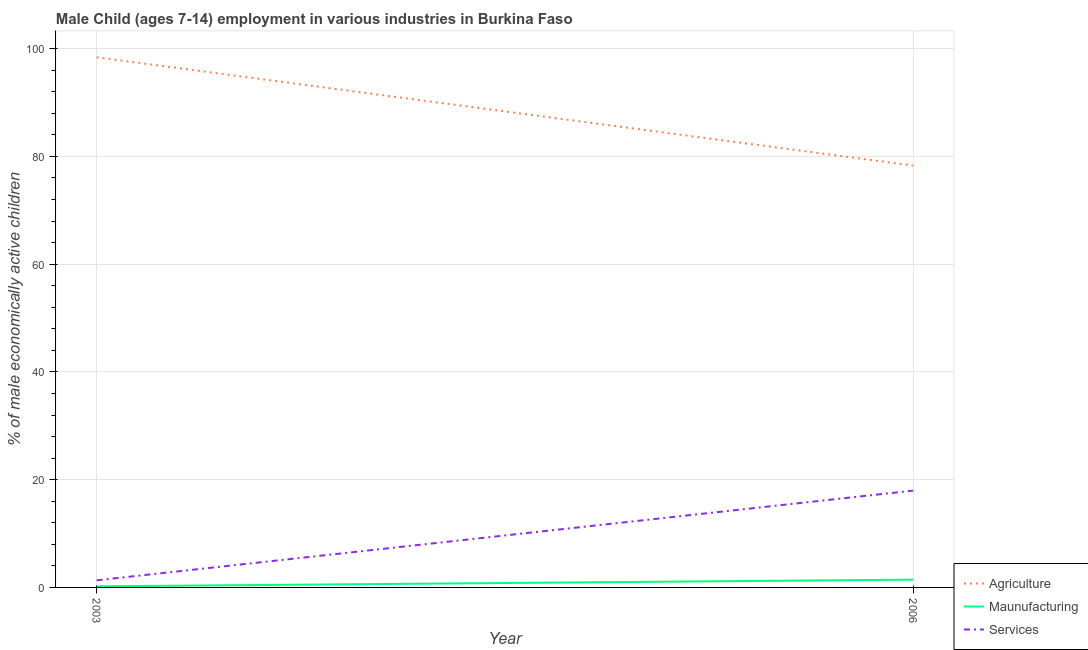How many different coloured lines are there?
Ensure brevity in your answer.  3. Is the number of lines equal to the number of legend labels?
Provide a succinct answer. Yes. What is the percentage of economically active children in manufacturing in 2006?
Your response must be concise. 1.44. Across all years, what is the maximum percentage of economically active children in services?
Provide a short and direct response. 17.97. Across all years, what is the minimum percentage of economically active children in agriculture?
Give a very brief answer. 78.3. In which year was the percentage of economically active children in manufacturing maximum?
Make the answer very short. 2006. In which year was the percentage of economically active children in services minimum?
Your response must be concise. 2003. What is the total percentage of economically active children in manufacturing in the graph?
Give a very brief answer. 1.64. What is the difference between the percentage of economically active children in manufacturing in 2003 and that in 2006?
Your answer should be compact. -1.24. What is the difference between the percentage of economically active children in agriculture in 2006 and the percentage of economically active children in services in 2003?
Ensure brevity in your answer.  76.98. What is the average percentage of economically active children in services per year?
Provide a succinct answer. 9.65. In the year 2003, what is the difference between the percentage of economically active children in agriculture and percentage of economically active children in manufacturing?
Make the answer very short. 98.2. What is the ratio of the percentage of economically active children in agriculture in 2003 to that in 2006?
Your answer should be compact. 1.26. Does the percentage of economically active children in manufacturing monotonically increase over the years?
Provide a succinct answer. Yes. Is the percentage of economically active children in services strictly less than the percentage of economically active children in manufacturing over the years?
Keep it short and to the point. No. How many lines are there?
Make the answer very short. 3. Does the graph contain grids?
Your answer should be compact. Yes. How are the legend labels stacked?
Offer a terse response. Vertical. What is the title of the graph?
Make the answer very short. Male Child (ages 7-14) employment in various industries in Burkina Faso. What is the label or title of the X-axis?
Ensure brevity in your answer.  Year. What is the label or title of the Y-axis?
Your answer should be compact. % of male economically active children. What is the % of male economically active children in Agriculture in 2003?
Your answer should be very brief. 98.4. What is the % of male economically active children of Maunufacturing in 2003?
Provide a succinct answer. 0.2. What is the % of male economically active children in Services in 2003?
Keep it short and to the point. 1.32. What is the % of male economically active children in Agriculture in 2006?
Provide a short and direct response. 78.3. What is the % of male economically active children of Maunufacturing in 2006?
Provide a short and direct response. 1.44. What is the % of male economically active children of Services in 2006?
Ensure brevity in your answer.  17.97. Across all years, what is the maximum % of male economically active children in Agriculture?
Offer a terse response. 98.4. Across all years, what is the maximum % of male economically active children of Maunufacturing?
Provide a succinct answer. 1.44. Across all years, what is the maximum % of male economically active children in Services?
Ensure brevity in your answer.  17.97. Across all years, what is the minimum % of male economically active children of Agriculture?
Give a very brief answer. 78.3. Across all years, what is the minimum % of male economically active children in Services?
Offer a very short reply. 1.32. What is the total % of male economically active children of Agriculture in the graph?
Offer a terse response. 176.7. What is the total % of male economically active children in Maunufacturing in the graph?
Provide a succinct answer. 1.64. What is the total % of male economically active children of Services in the graph?
Your answer should be compact. 19.29. What is the difference between the % of male economically active children in Agriculture in 2003 and that in 2006?
Make the answer very short. 20.1. What is the difference between the % of male economically active children in Maunufacturing in 2003 and that in 2006?
Give a very brief answer. -1.24. What is the difference between the % of male economically active children in Services in 2003 and that in 2006?
Your response must be concise. -16.65. What is the difference between the % of male economically active children of Agriculture in 2003 and the % of male economically active children of Maunufacturing in 2006?
Provide a succinct answer. 96.96. What is the difference between the % of male economically active children of Agriculture in 2003 and the % of male economically active children of Services in 2006?
Your answer should be very brief. 80.43. What is the difference between the % of male economically active children in Maunufacturing in 2003 and the % of male economically active children in Services in 2006?
Ensure brevity in your answer.  -17.77. What is the average % of male economically active children of Agriculture per year?
Provide a succinct answer. 88.35. What is the average % of male economically active children of Maunufacturing per year?
Offer a terse response. 0.82. What is the average % of male economically active children in Services per year?
Your answer should be compact. 9.65. In the year 2003, what is the difference between the % of male economically active children in Agriculture and % of male economically active children in Maunufacturing?
Offer a terse response. 98.2. In the year 2003, what is the difference between the % of male economically active children of Agriculture and % of male economically active children of Services?
Your answer should be very brief. 97.08. In the year 2003, what is the difference between the % of male economically active children in Maunufacturing and % of male economically active children in Services?
Offer a very short reply. -1.12. In the year 2006, what is the difference between the % of male economically active children in Agriculture and % of male economically active children in Maunufacturing?
Ensure brevity in your answer.  76.86. In the year 2006, what is the difference between the % of male economically active children in Agriculture and % of male economically active children in Services?
Your response must be concise. 60.33. In the year 2006, what is the difference between the % of male economically active children of Maunufacturing and % of male economically active children of Services?
Your answer should be compact. -16.53. What is the ratio of the % of male economically active children of Agriculture in 2003 to that in 2006?
Offer a very short reply. 1.26. What is the ratio of the % of male economically active children in Maunufacturing in 2003 to that in 2006?
Your answer should be very brief. 0.14. What is the ratio of the % of male economically active children in Services in 2003 to that in 2006?
Offer a very short reply. 0.07. What is the difference between the highest and the second highest % of male economically active children in Agriculture?
Provide a succinct answer. 20.1. What is the difference between the highest and the second highest % of male economically active children in Maunufacturing?
Make the answer very short. 1.24. What is the difference between the highest and the second highest % of male economically active children of Services?
Your answer should be compact. 16.65. What is the difference between the highest and the lowest % of male economically active children of Agriculture?
Provide a succinct answer. 20.1. What is the difference between the highest and the lowest % of male economically active children of Maunufacturing?
Your answer should be very brief. 1.24. What is the difference between the highest and the lowest % of male economically active children in Services?
Give a very brief answer. 16.65. 